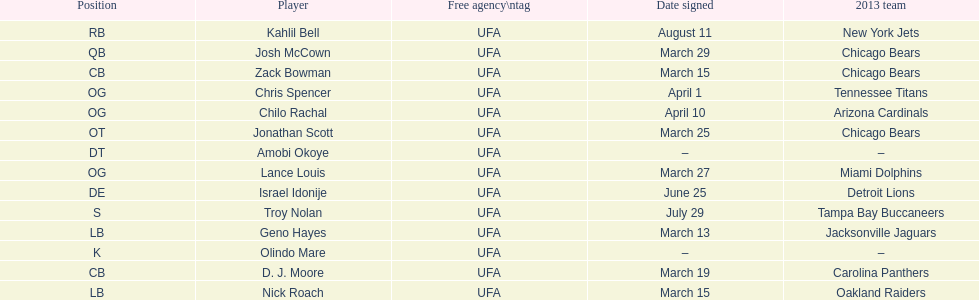How many free agents did this team pick up this season? 14. 